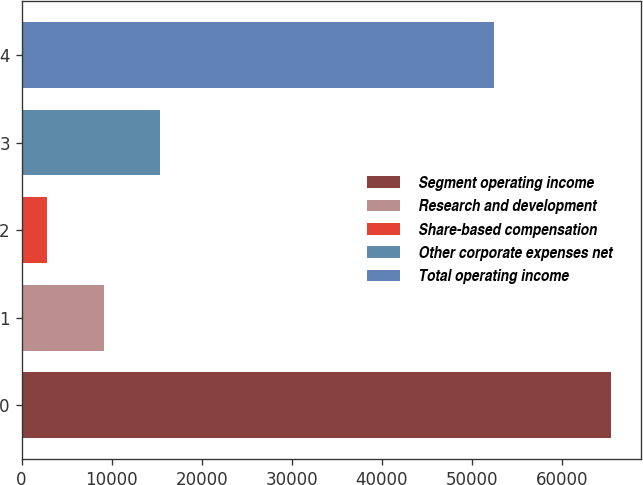<chart> <loc_0><loc_0><loc_500><loc_500><bar_chart><fcel>Segment operating income<fcel>Research and development<fcel>Share-based compensation<fcel>Other corporate expenses net<fcel>Total operating income<nl><fcel>65497<fcel>9126.4<fcel>2863<fcel>15389.8<fcel>52503<nl></chart> 